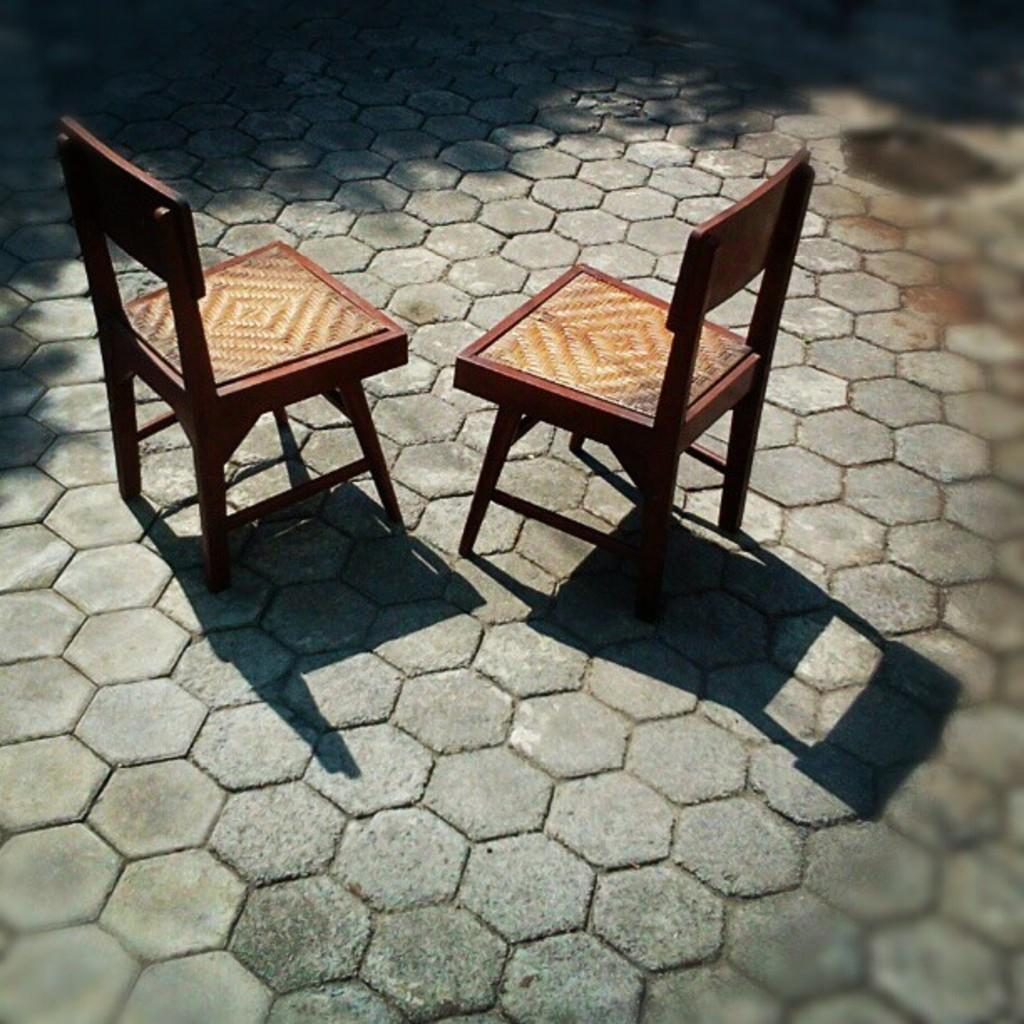How many chairs are visible in the image? There are two chairs in the image. Where are the chairs located? The chairs are on the road. What is the color of the chairs? The chairs are brown in color. What is the color of the road? The road is in ash color. What type of shirt is the toothbrush wearing in the image? There is no toothbrush or shirt present in the image; it features two chairs on the road. 